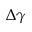<formula> <loc_0><loc_0><loc_500><loc_500>\Delta \gamma</formula> 